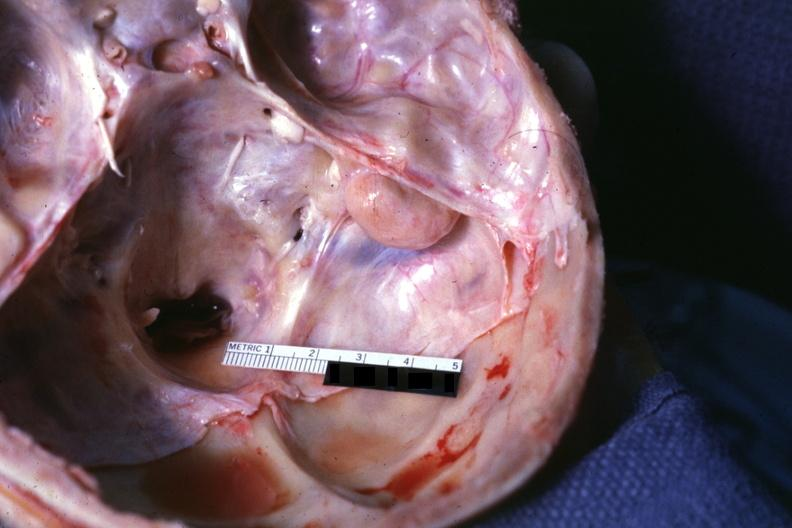s opened base of skull with brain removed?
Answer the question using a single word or phrase. Yes 